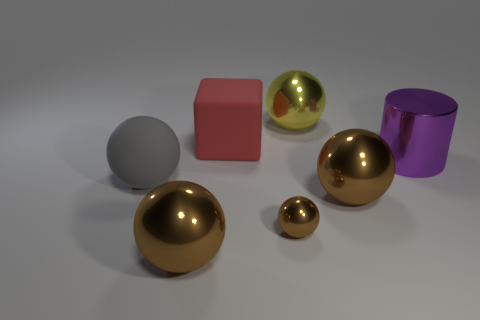Subtract all red blocks. How many brown balls are left? 3 Subtract 1 spheres. How many spheres are left? 4 Subtract all gray spheres. How many spheres are left? 4 Subtract all tiny spheres. How many spheres are left? 4 Subtract all purple spheres. Subtract all green cylinders. How many spheres are left? 5 Add 2 small rubber cylinders. How many objects exist? 9 Subtract all cylinders. How many objects are left? 6 Add 4 brown metallic things. How many brown metallic things exist? 7 Subtract 0 gray cubes. How many objects are left? 7 Subtract all large red matte things. Subtract all large metal cylinders. How many objects are left? 5 